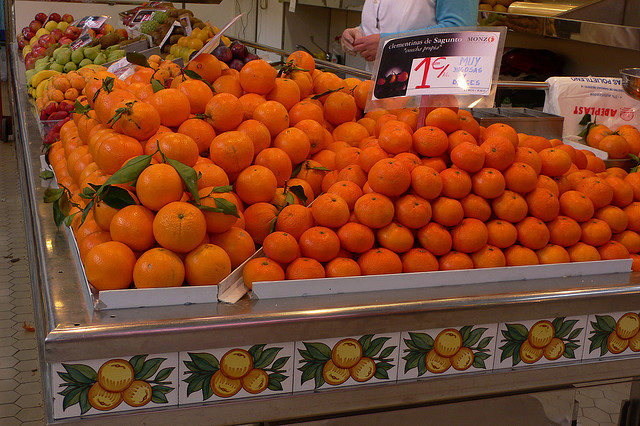Extract all visible text content from this image. 1 